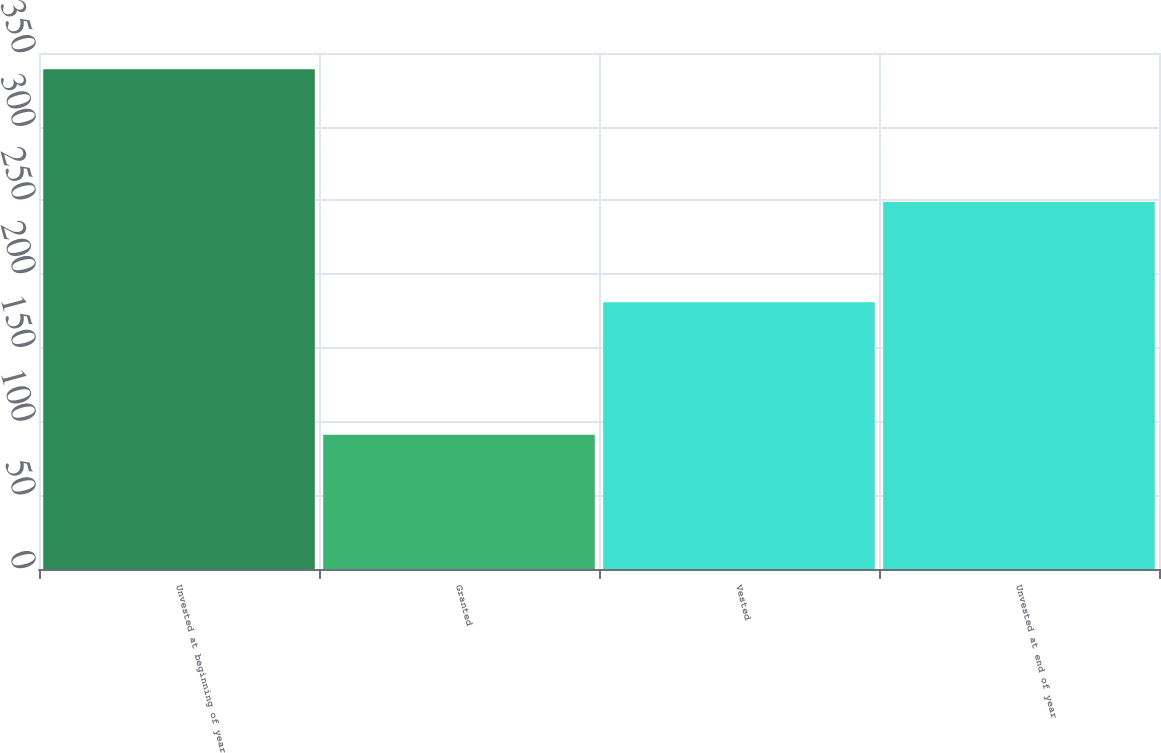<chart> <loc_0><loc_0><loc_500><loc_500><bar_chart><fcel>Unvested at beginning of year<fcel>Granted<fcel>Vested<fcel>Unvested at end of year<nl><fcel>339<fcel>91<fcel>181<fcel>249<nl></chart> 